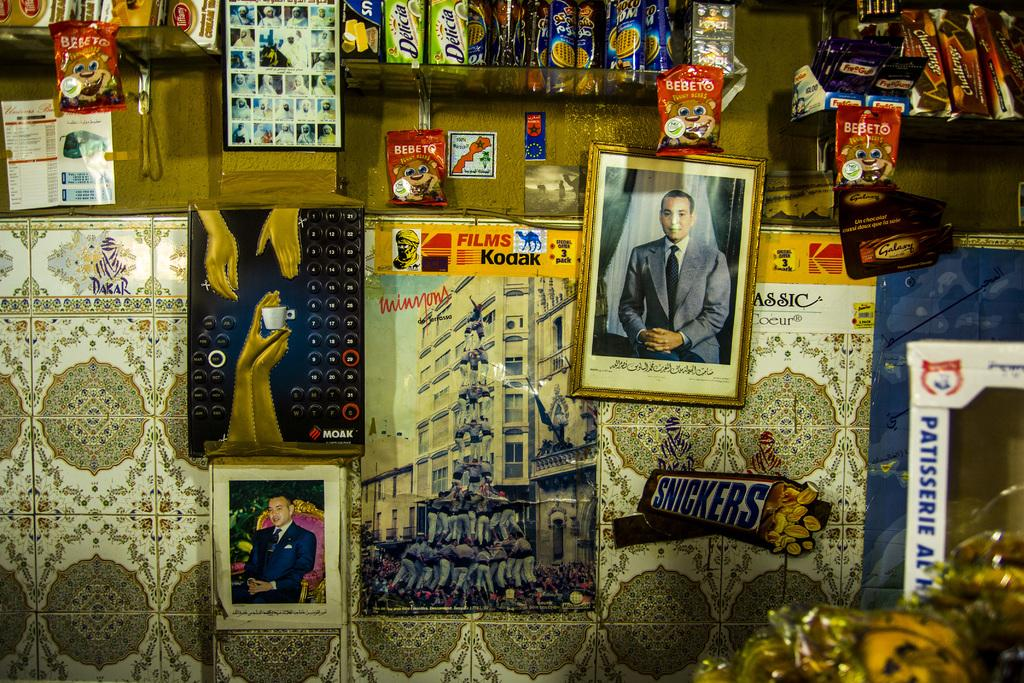What is attached to the wall in the image? There are frames attached to the wall in the image. What can be seen on the racks in the image? There are biscuit packets on the racks in the image. Are there any other items visible on the racks? Yes, there are other items on the racks in the image. How many brothers are present in the image? There is no reference to any brothers in the image. What type of trucks can be seen on the racks in the image? There are no trucks present in the image; it features frames on the wall and items on the racks. 